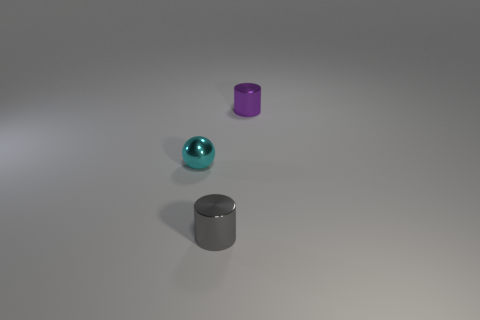Add 1 tiny blue cylinders. How many objects exist? 4 Add 3 small purple metallic cylinders. How many small purple metallic cylinders are left? 4 Add 1 small cyan metal spheres. How many small cyan metal spheres exist? 2 Subtract 0 green cylinders. How many objects are left? 3 Subtract all balls. How many objects are left? 2 Subtract all large red matte blocks. Subtract all metal cylinders. How many objects are left? 1 